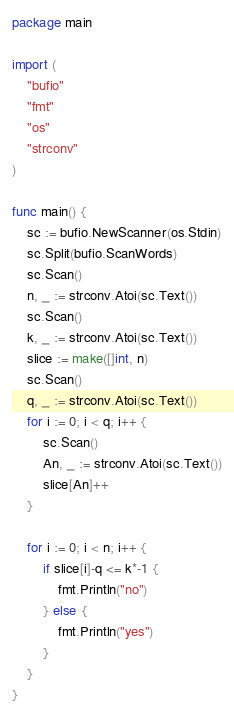Convert code to text. <code><loc_0><loc_0><loc_500><loc_500><_Go_>package main

import (
	"bufio"
	"fmt"
	"os"
	"strconv"
)

func main() {
	sc := bufio.NewScanner(os.Stdin)
	sc.Split(bufio.ScanWords)
	sc.Scan()
	n, _ := strconv.Atoi(sc.Text())
	sc.Scan()
	k, _ := strconv.Atoi(sc.Text())
	slice := make([]int, n)
	sc.Scan()
	q, _ := strconv.Atoi(sc.Text())
	for i := 0; i < q; i++ {
		sc.Scan()
		An, _ := strconv.Atoi(sc.Text())
		slice[An]++
	}

	for i := 0; i < n; i++ {
		if slice[i]-q <= k*-1 {
			fmt.Println("no")
		} else {
			fmt.Println("yes")
		}
	}
}
</code> 